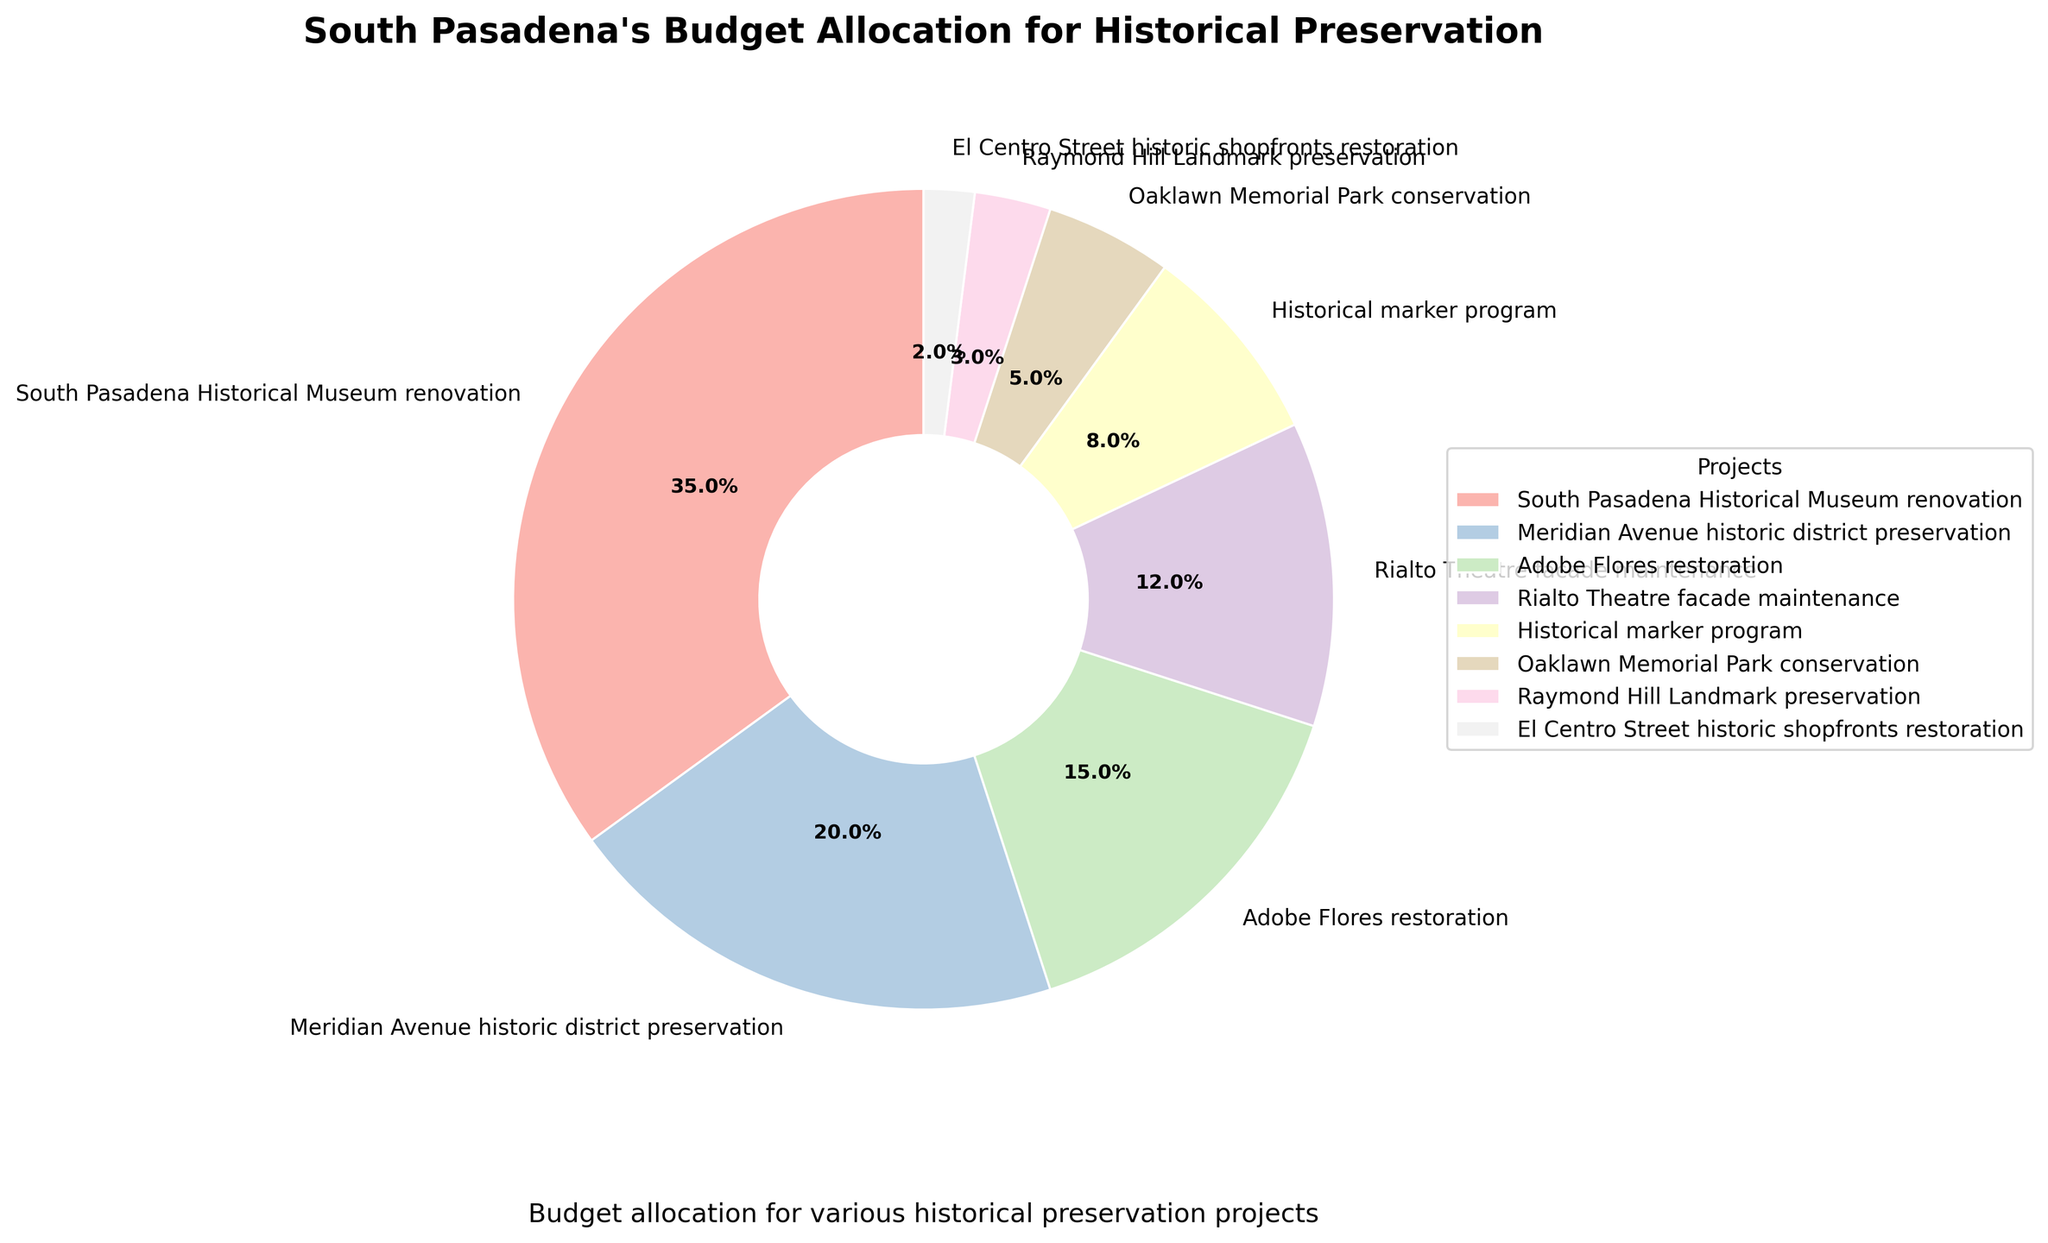Which project received the highest budget allocation? The project with the largest slice in the pie chart is the South Pasadena Historical Museum renovation, which received the highest budget allocation.
Answer: South Pasadena Historical Museum renovation What percentage of the budget was allocated to the Meridian Avenue historic district preservation? The pie chart shows that the slice for Meridian Avenue historic district preservation is labeled with a percentage of 20%.
Answer: 20% How does the budget allocation for Adobe Flores restoration compare to that for Rialto Theatre facade maintenance? By examining the sizes of the slices and their respective percentages from the pie chart, it is evident that Adobe Flores restoration received 15% of the budget, while Rialto Theatre facade maintenance received 12%. Therefore, Adobe Flores restoration has a 3% higher allocation.
Answer: Adobe Flores restoration received 3% more What is the total budget allocation for projects other than the South Pasadena Historical Museum renovation? Excluding the 35% allocated to the South Pasadena Historical Museum renovation, the remaining budget covers all other projects. Summing up the remaining percentages: 20% (Meridian Avenue) + 15% (Adobe Flores) + 12% (Rialto Theatre) + 8% (Historical marker program) + 5% (Oaklawn Memorial Park) + 3% (Raymond Hill) + 2% (El Centro Street) = 65%.
Answer: 65% Are there any projects with less than 10% budget allocation, and if so, which ones? From the pie chart, the projects with slices indicating less than 10% budget allocation are the Historical marker program (8%), Oaklawn Memorial Park conservation (5%), Raymond Hill Landmark preservation (3%), and El Centro Street historic shopfronts restoration (2%).
Answer: Historical marker program, Oaklawn Memorial Park conservation, Raymond Hill Landmark preservation, El Centro Street historic shopfronts restoration What is the combined budget allocation for the South Pasadena Historical Museum renovation and the Meridian Avenue historic district preservation? Adding the percentages from the pie chart for South Pasadena Historical Museum renovation (35%) and Meridian Avenue historic district preservation (20%) gives: 35% + 20% = 55%.
Answer: 55% What fraction of the budget allocation went to the least funded project? The pie chart shows that the El Centro Street historic shopfronts restoration received the smallest slice which is 2%. This is 2/100 or 1/50 of the total budget.
Answer: 1/50 How much more budget allocation did the Adobe Flores restoration receive than the Oaklawn Memorial Park conservation? Referring to the pie chart, Adobe Flores restoration got 15% of the budget, and Oaklawn Memorial Park conservation got 5%. The difference in their allocations is 15% - 5% = 10%.
Answer: 10% Compare the budget allocations for the Raymond Hill Landmark preservation and the Historical marker program. The pie chart indicates that the Raymond Hill Landmark preservation received 3% of the budget, while the Historical marker program received 8%. Therefore, the Historical marker program received 5% more funds.
Answer: Historical marker program received 5% more 